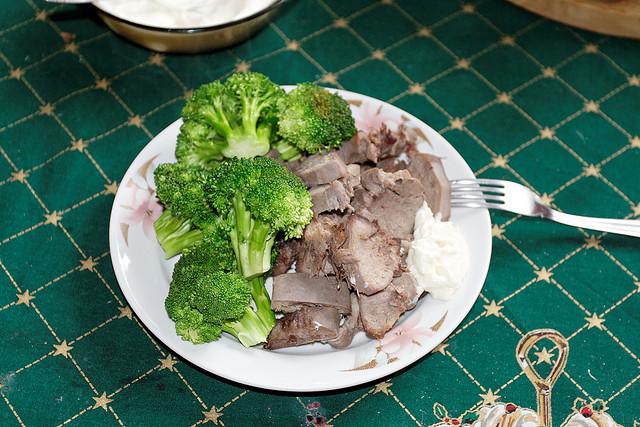What is the green vegetable?
Write a very short answer. Broccoli. What utensils are in this picture?
Keep it brief. Fork. Where are the stars?
Keep it brief. Tablecloth. 